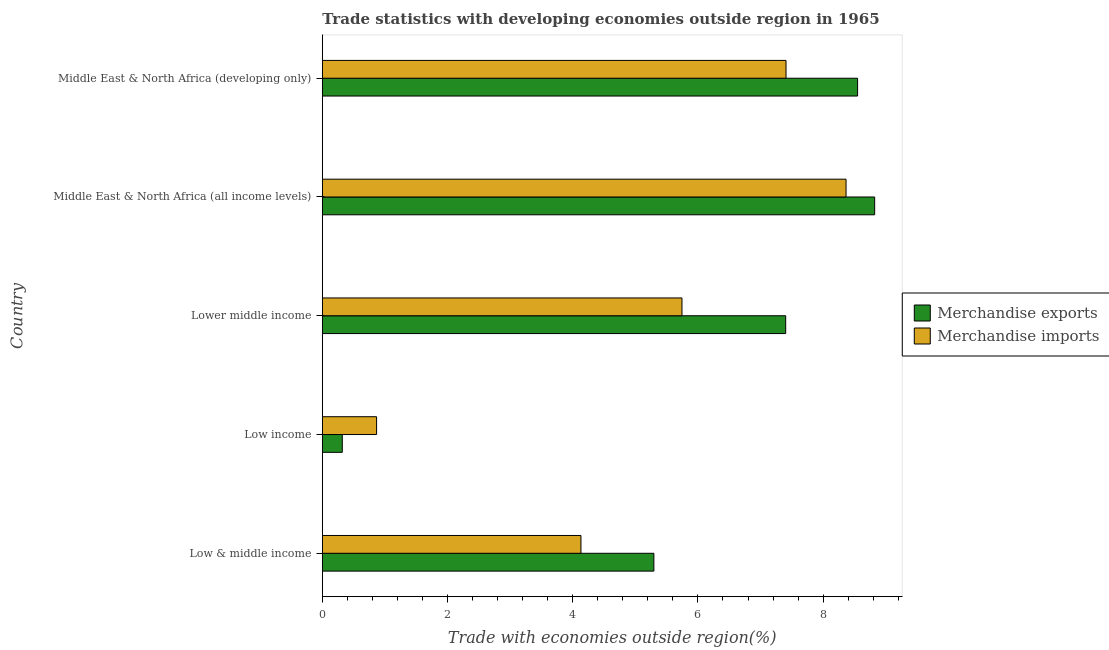How many groups of bars are there?
Make the answer very short. 5. What is the label of the 1st group of bars from the top?
Offer a terse response. Middle East & North Africa (developing only). In how many cases, is the number of bars for a given country not equal to the number of legend labels?
Keep it short and to the point. 0. What is the merchandise exports in Low income?
Give a very brief answer. 0.32. Across all countries, what is the maximum merchandise exports?
Offer a terse response. 8.82. Across all countries, what is the minimum merchandise exports?
Offer a terse response. 0.32. In which country was the merchandise imports maximum?
Your answer should be compact. Middle East & North Africa (all income levels). In which country was the merchandise imports minimum?
Keep it short and to the point. Low income. What is the total merchandise imports in the graph?
Offer a terse response. 26.52. What is the difference between the merchandise imports in Low income and that in Middle East & North Africa (developing only)?
Provide a short and direct response. -6.54. What is the difference between the merchandise exports in Low & middle income and the merchandise imports in Lower middle income?
Provide a succinct answer. -0.45. What is the average merchandise imports per country?
Offer a very short reply. 5.3. What is the difference between the merchandise imports and merchandise exports in Low & middle income?
Offer a terse response. -1.17. In how many countries, is the merchandise exports greater than 3.6 %?
Provide a succinct answer. 4. What is the ratio of the merchandise imports in Low income to that in Middle East & North Africa (all income levels)?
Ensure brevity in your answer.  0.1. Is the difference between the merchandise exports in Low & middle income and Middle East & North Africa (developing only) greater than the difference between the merchandise imports in Low & middle income and Middle East & North Africa (developing only)?
Provide a succinct answer. Yes. What is the difference between the highest and the second highest merchandise imports?
Your answer should be very brief. 0.96. What is the difference between the highest and the lowest merchandise exports?
Provide a short and direct response. 8.5. What does the 1st bar from the top in Lower middle income represents?
Keep it short and to the point. Merchandise imports. Where does the legend appear in the graph?
Provide a short and direct response. Center right. How are the legend labels stacked?
Ensure brevity in your answer.  Vertical. What is the title of the graph?
Provide a short and direct response. Trade statistics with developing economies outside region in 1965. Does "Borrowers" appear as one of the legend labels in the graph?
Keep it short and to the point. No. What is the label or title of the X-axis?
Give a very brief answer. Trade with economies outside region(%). What is the label or title of the Y-axis?
Provide a succinct answer. Country. What is the Trade with economies outside region(%) of Merchandise exports in Low & middle income?
Ensure brevity in your answer.  5.3. What is the Trade with economies outside region(%) in Merchandise imports in Low & middle income?
Provide a short and direct response. 4.13. What is the Trade with economies outside region(%) in Merchandise exports in Low income?
Your answer should be compact. 0.32. What is the Trade with economies outside region(%) of Merchandise imports in Low income?
Give a very brief answer. 0.87. What is the Trade with economies outside region(%) of Merchandise exports in Lower middle income?
Keep it short and to the point. 7.4. What is the Trade with economies outside region(%) in Merchandise imports in Lower middle income?
Your response must be concise. 5.74. What is the Trade with economies outside region(%) of Merchandise exports in Middle East & North Africa (all income levels)?
Offer a terse response. 8.82. What is the Trade with economies outside region(%) of Merchandise imports in Middle East & North Africa (all income levels)?
Provide a short and direct response. 8.37. What is the Trade with economies outside region(%) of Merchandise exports in Middle East & North Africa (developing only)?
Offer a very short reply. 8.55. What is the Trade with economies outside region(%) in Merchandise imports in Middle East & North Africa (developing only)?
Provide a succinct answer. 7.41. Across all countries, what is the maximum Trade with economies outside region(%) of Merchandise exports?
Ensure brevity in your answer.  8.82. Across all countries, what is the maximum Trade with economies outside region(%) in Merchandise imports?
Your answer should be compact. 8.37. Across all countries, what is the minimum Trade with economies outside region(%) in Merchandise exports?
Keep it short and to the point. 0.32. Across all countries, what is the minimum Trade with economies outside region(%) in Merchandise imports?
Your answer should be very brief. 0.87. What is the total Trade with economies outside region(%) in Merchandise exports in the graph?
Your answer should be very brief. 30.39. What is the total Trade with economies outside region(%) in Merchandise imports in the graph?
Offer a terse response. 26.52. What is the difference between the Trade with economies outside region(%) of Merchandise exports in Low & middle income and that in Low income?
Give a very brief answer. 4.98. What is the difference between the Trade with economies outside region(%) in Merchandise imports in Low & middle income and that in Low income?
Make the answer very short. 3.26. What is the difference between the Trade with economies outside region(%) in Merchandise exports in Low & middle income and that in Lower middle income?
Ensure brevity in your answer.  -2.11. What is the difference between the Trade with economies outside region(%) in Merchandise imports in Low & middle income and that in Lower middle income?
Offer a very short reply. -1.61. What is the difference between the Trade with economies outside region(%) of Merchandise exports in Low & middle income and that in Middle East & North Africa (all income levels)?
Your answer should be very brief. -3.53. What is the difference between the Trade with economies outside region(%) in Merchandise imports in Low & middle income and that in Middle East & North Africa (all income levels)?
Provide a succinct answer. -4.23. What is the difference between the Trade with economies outside region(%) of Merchandise exports in Low & middle income and that in Middle East & North Africa (developing only)?
Provide a succinct answer. -3.25. What is the difference between the Trade with economies outside region(%) in Merchandise imports in Low & middle income and that in Middle East & North Africa (developing only)?
Make the answer very short. -3.28. What is the difference between the Trade with economies outside region(%) of Merchandise exports in Low income and that in Lower middle income?
Offer a very short reply. -7.08. What is the difference between the Trade with economies outside region(%) in Merchandise imports in Low income and that in Lower middle income?
Keep it short and to the point. -4.88. What is the difference between the Trade with economies outside region(%) of Merchandise exports in Low income and that in Middle East & North Africa (all income levels)?
Your answer should be very brief. -8.5. What is the difference between the Trade with economies outside region(%) in Merchandise imports in Low income and that in Middle East & North Africa (all income levels)?
Ensure brevity in your answer.  -7.5. What is the difference between the Trade with economies outside region(%) in Merchandise exports in Low income and that in Middle East & North Africa (developing only)?
Your response must be concise. -8.23. What is the difference between the Trade with economies outside region(%) of Merchandise imports in Low income and that in Middle East & North Africa (developing only)?
Offer a very short reply. -6.54. What is the difference between the Trade with economies outside region(%) of Merchandise exports in Lower middle income and that in Middle East & North Africa (all income levels)?
Give a very brief answer. -1.42. What is the difference between the Trade with economies outside region(%) of Merchandise imports in Lower middle income and that in Middle East & North Africa (all income levels)?
Offer a very short reply. -2.62. What is the difference between the Trade with economies outside region(%) of Merchandise exports in Lower middle income and that in Middle East & North Africa (developing only)?
Your answer should be very brief. -1.15. What is the difference between the Trade with economies outside region(%) of Merchandise imports in Lower middle income and that in Middle East & North Africa (developing only)?
Your response must be concise. -1.66. What is the difference between the Trade with economies outside region(%) of Merchandise exports in Middle East & North Africa (all income levels) and that in Middle East & North Africa (developing only)?
Offer a terse response. 0.27. What is the difference between the Trade with economies outside region(%) of Merchandise imports in Middle East & North Africa (all income levels) and that in Middle East & North Africa (developing only)?
Give a very brief answer. 0.96. What is the difference between the Trade with economies outside region(%) of Merchandise exports in Low & middle income and the Trade with economies outside region(%) of Merchandise imports in Low income?
Offer a terse response. 4.43. What is the difference between the Trade with economies outside region(%) in Merchandise exports in Low & middle income and the Trade with economies outside region(%) in Merchandise imports in Lower middle income?
Offer a terse response. -0.45. What is the difference between the Trade with economies outside region(%) in Merchandise exports in Low & middle income and the Trade with economies outside region(%) in Merchandise imports in Middle East & North Africa (all income levels)?
Provide a short and direct response. -3.07. What is the difference between the Trade with economies outside region(%) of Merchandise exports in Low & middle income and the Trade with economies outside region(%) of Merchandise imports in Middle East & North Africa (developing only)?
Keep it short and to the point. -2.11. What is the difference between the Trade with economies outside region(%) of Merchandise exports in Low income and the Trade with economies outside region(%) of Merchandise imports in Lower middle income?
Your response must be concise. -5.43. What is the difference between the Trade with economies outside region(%) of Merchandise exports in Low income and the Trade with economies outside region(%) of Merchandise imports in Middle East & North Africa (all income levels)?
Your answer should be very brief. -8.05. What is the difference between the Trade with economies outside region(%) in Merchandise exports in Low income and the Trade with economies outside region(%) in Merchandise imports in Middle East & North Africa (developing only)?
Provide a short and direct response. -7.09. What is the difference between the Trade with economies outside region(%) of Merchandise exports in Lower middle income and the Trade with economies outside region(%) of Merchandise imports in Middle East & North Africa (all income levels)?
Provide a succinct answer. -0.96. What is the difference between the Trade with economies outside region(%) of Merchandise exports in Lower middle income and the Trade with economies outside region(%) of Merchandise imports in Middle East & North Africa (developing only)?
Keep it short and to the point. -0.01. What is the difference between the Trade with economies outside region(%) of Merchandise exports in Middle East & North Africa (all income levels) and the Trade with economies outside region(%) of Merchandise imports in Middle East & North Africa (developing only)?
Offer a terse response. 1.42. What is the average Trade with economies outside region(%) in Merchandise exports per country?
Offer a very short reply. 6.08. What is the average Trade with economies outside region(%) in Merchandise imports per country?
Your answer should be compact. 5.3. What is the difference between the Trade with economies outside region(%) of Merchandise exports and Trade with economies outside region(%) of Merchandise imports in Low & middle income?
Offer a very short reply. 1.17. What is the difference between the Trade with economies outside region(%) in Merchandise exports and Trade with economies outside region(%) in Merchandise imports in Low income?
Provide a succinct answer. -0.55. What is the difference between the Trade with economies outside region(%) of Merchandise exports and Trade with economies outside region(%) of Merchandise imports in Lower middle income?
Provide a short and direct response. 1.66. What is the difference between the Trade with economies outside region(%) in Merchandise exports and Trade with economies outside region(%) in Merchandise imports in Middle East & North Africa (all income levels)?
Your answer should be compact. 0.46. What is the difference between the Trade with economies outside region(%) of Merchandise exports and Trade with economies outside region(%) of Merchandise imports in Middle East & North Africa (developing only)?
Provide a succinct answer. 1.14. What is the ratio of the Trade with economies outside region(%) in Merchandise exports in Low & middle income to that in Low income?
Provide a short and direct response. 16.61. What is the ratio of the Trade with economies outside region(%) of Merchandise imports in Low & middle income to that in Low income?
Ensure brevity in your answer.  4.77. What is the ratio of the Trade with economies outside region(%) in Merchandise exports in Low & middle income to that in Lower middle income?
Your answer should be very brief. 0.72. What is the ratio of the Trade with economies outside region(%) in Merchandise imports in Low & middle income to that in Lower middle income?
Your answer should be very brief. 0.72. What is the ratio of the Trade with economies outside region(%) of Merchandise exports in Low & middle income to that in Middle East & North Africa (all income levels)?
Give a very brief answer. 0.6. What is the ratio of the Trade with economies outside region(%) of Merchandise imports in Low & middle income to that in Middle East & North Africa (all income levels)?
Your answer should be very brief. 0.49. What is the ratio of the Trade with economies outside region(%) in Merchandise exports in Low & middle income to that in Middle East & North Africa (developing only)?
Offer a very short reply. 0.62. What is the ratio of the Trade with economies outside region(%) of Merchandise imports in Low & middle income to that in Middle East & North Africa (developing only)?
Keep it short and to the point. 0.56. What is the ratio of the Trade with economies outside region(%) in Merchandise exports in Low income to that in Lower middle income?
Offer a terse response. 0.04. What is the ratio of the Trade with economies outside region(%) of Merchandise imports in Low income to that in Lower middle income?
Provide a succinct answer. 0.15. What is the ratio of the Trade with economies outside region(%) in Merchandise exports in Low income to that in Middle East & North Africa (all income levels)?
Ensure brevity in your answer.  0.04. What is the ratio of the Trade with economies outside region(%) in Merchandise imports in Low income to that in Middle East & North Africa (all income levels)?
Give a very brief answer. 0.1. What is the ratio of the Trade with economies outside region(%) in Merchandise exports in Low income to that in Middle East & North Africa (developing only)?
Offer a terse response. 0.04. What is the ratio of the Trade with economies outside region(%) of Merchandise imports in Low income to that in Middle East & North Africa (developing only)?
Your answer should be very brief. 0.12. What is the ratio of the Trade with economies outside region(%) in Merchandise exports in Lower middle income to that in Middle East & North Africa (all income levels)?
Your response must be concise. 0.84. What is the ratio of the Trade with economies outside region(%) in Merchandise imports in Lower middle income to that in Middle East & North Africa (all income levels)?
Keep it short and to the point. 0.69. What is the ratio of the Trade with economies outside region(%) of Merchandise exports in Lower middle income to that in Middle East & North Africa (developing only)?
Offer a very short reply. 0.87. What is the ratio of the Trade with economies outside region(%) in Merchandise imports in Lower middle income to that in Middle East & North Africa (developing only)?
Make the answer very short. 0.78. What is the ratio of the Trade with economies outside region(%) of Merchandise exports in Middle East & North Africa (all income levels) to that in Middle East & North Africa (developing only)?
Ensure brevity in your answer.  1.03. What is the ratio of the Trade with economies outside region(%) in Merchandise imports in Middle East & North Africa (all income levels) to that in Middle East & North Africa (developing only)?
Offer a very short reply. 1.13. What is the difference between the highest and the second highest Trade with economies outside region(%) of Merchandise exports?
Provide a short and direct response. 0.27. What is the difference between the highest and the second highest Trade with economies outside region(%) of Merchandise imports?
Give a very brief answer. 0.96. What is the difference between the highest and the lowest Trade with economies outside region(%) of Merchandise exports?
Give a very brief answer. 8.5. What is the difference between the highest and the lowest Trade with economies outside region(%) of Merchandise imports?
Give a very brief answer. 7.5. 